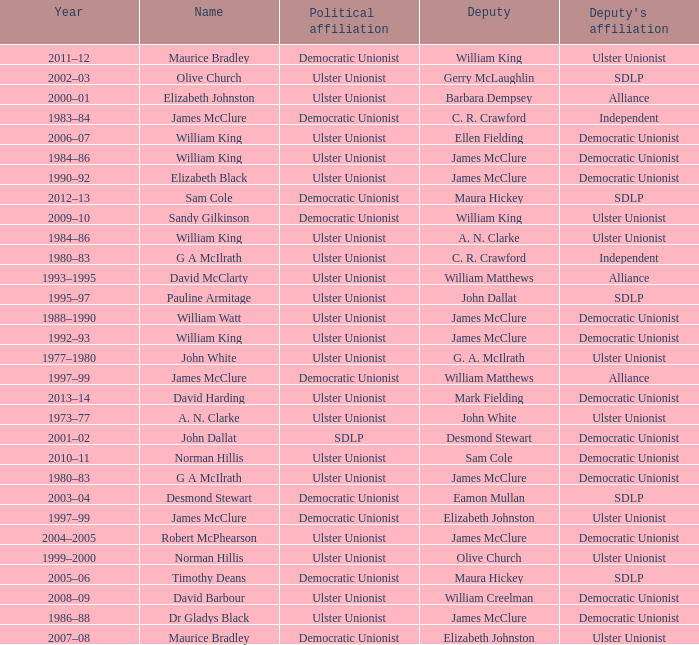What is the Deputy's affiliation in 1992–93? Democratic Unionist. 